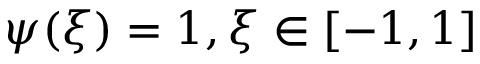<formula> <loc_0><loc_0><loc_500><loc_500>\psi ( \xi ) = 1 , \xi \in [ - 1 , 1 ]</formula> 